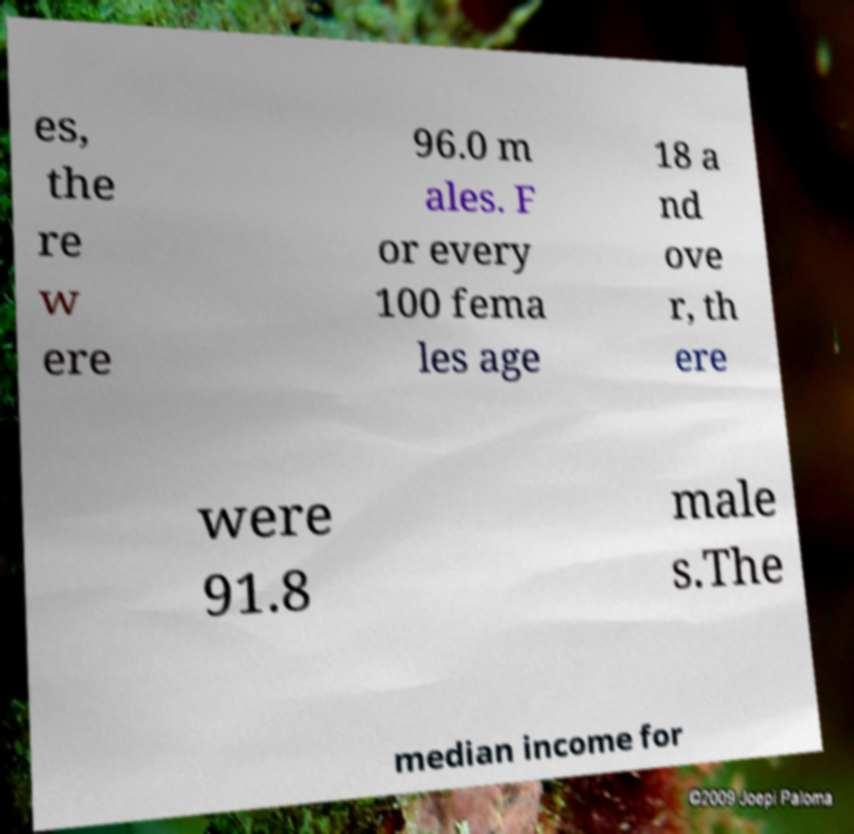Please read and relay the text visible in this image. What does it say? es, the re w ere 96.0 m ales. F or every 100 fema les age 18 a nd ove r, th ere were 91.8 male s.The median income for 